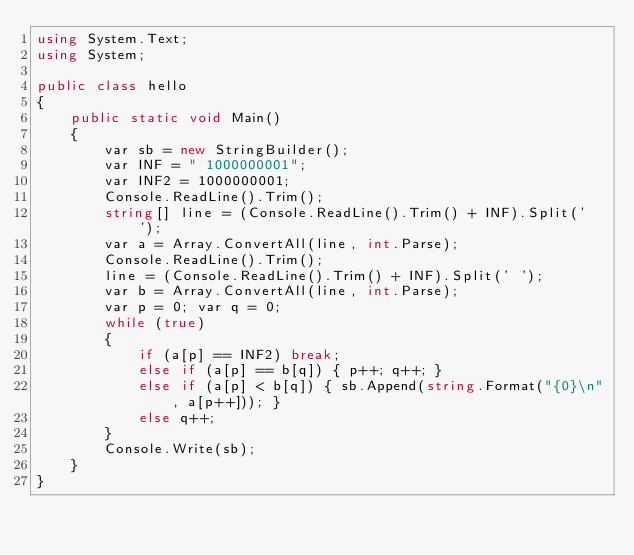Convert code to text. <code><loc_0><loc_0><loc_500><loc_500><_C#_>using System.Text;
using System;

public class hello
{
    public static void Main()
    {
        var sb = new StringBuilder();
        var INF = " 1000000001";
        var INF2 = 1000000001;
        Console.ReadLine().Trim();
        string[] line = (Console.ReadLine().Trim() + INF).Split(' ');
        var a = Array.ConvertAll(line, int.Parse);
        Console.ReadLine().Trim();
        line = (Console.ReadLine().Trim() + INF).Split(' ');
        var b = Array.ConvertAll(line, int.Parse);
        var p = 0; var q = 0;
        while (true)
        {
            if (a[p] == INF2) break;
            else if (a[p] == b[q]) { p++; q++; }
            else if (a[p] < b[q]) { sb.Append(string.Format("{0}\n", a[p++])); }
            else q++;
        }
        Console.Write(sb);
    }
}
</code> 